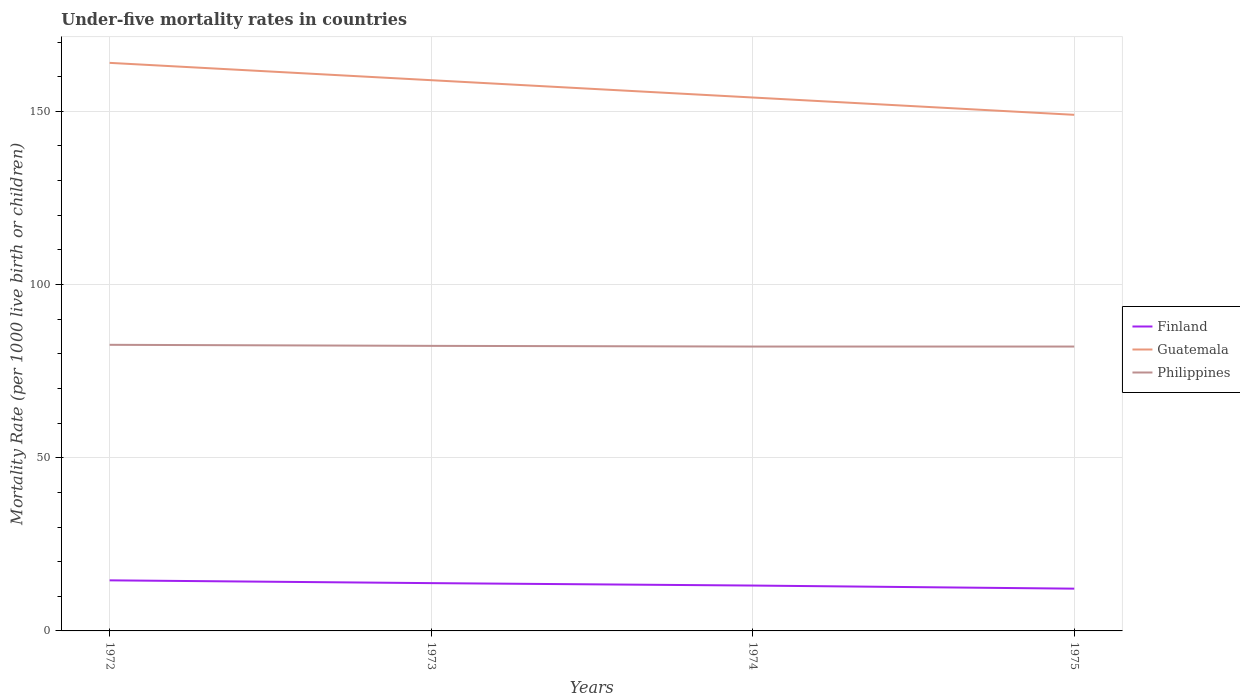How many different coloured lines are there?
Your response must be concise. 3. Does the line corresponding to Guatemala intersect with the line corresponding to Finland?
Keep it short and to the point. No. Is the number of lines equal to the number of legend labels?
Provide a succinct answer. Yes. Across all years, what is the maximum under-five mortality rate in Finland?
Your response must be concise. 12.2. In which year was the under-five mortality rate in Finland maximum?
Your response must be concise. 1975. What is the total under-five mortality rate in Guatemala in the graph?
Keep it short and to the point. 5. What is the difference between the highest and the lowest under-five mortality rate in Guatemala?
Your answer should be compact. 2. How many lines are there?
Make the answer very short. 3. What is the difference between two consecutive major ticks on the Y-axis?
Ensure brevity in your answer.  50. Does the graph contain any zero values?
Provide a succinct answer. No. Where does the legend appear in the graph?
Provide a short and direct response. Center right. How many legend labels are there?
Offer a very short reply. 3. How are the legend labels stacked?
Keep it short and to the point. Vertical. What is the title of the graph?
Offer a very short reply. Under-five mortality rates in countries. What is the label or title of the Y-axis?
Provide a succinct answer. Mortality Rate (per 1000 live birth or children). What is the Mortality Rate (per 1000 live birth or children) in Guatemala in 1972?
Give a very brief answer. 164. What is the Mortality Rate (per 1000 live birth or children) in Philippines in 1972?
Your answer should be compact. 82.6. What is the Mortality Rate (per 1000 live birth or children) in Guatemala in 1973?
Offer a very short reply. 159. What is the Mortality Rate (per 1000 live birth or children) in Philippines in 1973?
Provide a succinct answer. 82.3. What is the Mortality Rate (per 1000 live birth or children) in Finland in 1974?
Your answer should be very brief. 13.1. What is the Mortality Rate (per 1000 live birth or children) of Guatemala in 1974?
Give a very brief answer. 154. What is the Mortality Rate (per 1000 live birth or children) in Philippines in 1974?
Your answer should be very brief. 82.1. What is the Mortality Rate (per 1000 live birth or children) of Guatemala in 1975?
Offer a very short reply. 149. What is the Mortality Rate (per 1000 live birth or children) in Philippines in 1975?
Your answer should be very brief. 82.1. Across all years, what is the maximum Mortality Rate (per 1000 live birth or children) of Guatemala?
Your answer should be compact. 164. Across all years, what is the maximum Mortality Rate (per 1000 live birth or children) in Philippines?
Offer a very short reply. 82.6. Across all years, what is the minimum Mortality Rate (per 1000 live birth or children) of Guatemala?
Provide a short and direct response. 149. Across all years, what is the minimum Mortality Rate (per 1000 live birth or children) in Philippines?
Your response must be concise. 82.1. What is the total Mortality Rate (per 1000 live birth or children) in Finland in the graph?
Give a very brief answer. 53.7. What is the total Mortality Rate (per 1000 live birth or children) of Guatemala in the graph?
Offer a terse response. 626. What is the total Mortality Rate (per 1000 live birth or children) in Philippines in the graph?
Keep it short and to the point. 329.1. What is the difference between the Mortality Rate (per 1000 live birth or children) in Guatemala in 1972 and that in 1973?
Offer a terse response. 5. What is the difference between the Mortality Rate (per 1000 live birth or children) of Philippines in 1972 and that in 1973?
Provide a short and direct response. 0.3. What is the difference between the Mortality Rate (per 1000 live birth or children) in Finland in 1972 and that in 1974?
Provide a succinct answer. 1.5. What is the difference between the Mortality Rate (per 1000 live birth or children) in Philippines in 1972 and that in 1974?
Your answer should be compact. 0.5. What is the difference between the Mortality Rate (per 1000 live birth or children) of Finland in 1972 and that in 1975?
Your answer should be compact. 2.4. What is the difference between the Mortality Rate (per 1000 live birth or children) of Guatemala in 1972 and that in 1975?
Keep it short and to the point. 15. What is the difference between the Mortality Rate (per 1000 live birth or children) in Philippines in 1972 and that in 1975?
Your response must be concise. 0.5. What is the difference between the Mortality Rate (per 1000 live birth or children) in Finland in 1973 and that in 1974?
Provide a succinct answer. 0.7. What is the difference between the Mortality Rate (per 1000 live birth or children) in Philippines in 1973 and that in 1974?
Offer a very short reply. 0.2. What is the difference between the Mortality Rate (per 1000 live birth or children) in Finland in 1973 and that in 1975?
Offer a very short reply. 1.6. What is the difference between the Mortality Rate (per 1000 live birth or children) in Philippines in 1973 and that in 1975?
Provide a succinct answer. 0.2. What is the difference between the Mortality Rate (per 1000 live birth or children) in Finland in 1974 and that in 1975?
Provide a short and direct response. 0.9. What is the difference between the Mortality Rate (per 1000 live birth or children) of Finland in 1972 and the Mortality Rate (per 1000 live birth or children) of Guatemala in 1973?
Give a very brief answer. -144.4. What is the difference between the Mortality Rate (per 1000 live birth or children) of Finland in 1972 and the Mortality Rate (per 1000 live birth or children) of Philippines in 1973?
Your response must be concise. -67.7. What is the difference between the Mortality Rate (per 1000 live birth or children) of Guatemala in 1972 and the Mortality Rate (per 1000 live birth or children) of Philippines in 1973?
Provide a short and direct response. 81.7. What is the difference between the Mortality Rate (per 1000 live birth or children) in Finland in 1972 and the Mortality Rate (per 1000 live birth or children) in Guatemala in 1974?
Provide a succinct answer. -139.4. What is the difference between the Mortality Rate (per 1000 live birth or children) of Finland in 1972 and the Mortality Rate (per 1000 live birth or children) of Philippines in 1974?
Keep it short and to the point. -67.5. What is the difference between the Mortality Rate (per 1000 live birth or children) of Guatemala in 1972 and the Mortality Rate (per 1000 live birth or children) of Philippines in 1974?
Your response must be concise. 81.9. What is the difference between the Mortality Rate (per 1000 live birth or children) of Finland in 1972 and the Mortality Rate (per 1000 live birth or children) of Guatemala in 1975?
Make the answer very short. -134.4. What is the difference between the Mortality Rate (per 1000 live birth or children) in Finland in 1972 and the Mortality Rate (per 1000 live birth or children) in Philippines in 1975?
Give a very brief answer. -67.5. What is the difference between the Mortality Rate (per 1000 live birth or children) in Guatemala in 1972 and the Mortality Rate (per 1000 live birth or children) in Philippines in 1975?
Provide a short and direct response. 81.9. What is the difference between the Mortality Rate (per 1000 live birth or children) of Finland in 1973 and the Mortality Rate (per 1000 live birth or children) of Guatemala in 1974?
Offer a very short reply. -140.2. What is the difference between the Mortality Rate (per 1000 live birth or children) in Finland in 1973 and the Mortality Rate (per 1000 live birth or children) in Philippines in 1974?
Offer a terse response. -68.3. What is the difference between the Mortality Rate (per 1000 live birth or children) of Guatemala in 1973 and the Mortality Rate (per 1000 live birth or children) of Philippines in 1974?
Your response must be concise. 76.9. What is the difference between the Mortality Rate (per 1000 live birth or children) in Finland in 1973 and the Mortality Rate (per 1000 live birth or children) in Guatemala in 1975?
Your answer should be very brief. -135.2. What is the difference between the Mortality Rate (per 1000 live birth or children) in Finland in 1973 and the Mortality Rate (per 1000 live birth or children) in Philippines in 1975?
Your answer should be compact. -68.3. What is the difference between the Mortality Rate (per 1000 live birth or children) of Guatemala in 1973 and the Mortality Rate (per 1000 live birth or children) of Philippines in 1975?
Make the answer very short. 76.9. What is the difference between the Mortality Rate (per 1000 live birth or children) of Finland in 1974 and the Mortality Rate (per 1000 live birth or children) of Guatemala in 1975?
Your answer should be very brief. -135.9. What is the difference between the Mortality Rate (per 1000 live birth or children) in Finland in 1974 and the Mortality Rate (per 1000 live birth or children) in Philippines in 1975?
Provide a short and direct response. -69. What is the difference between the Mortality Rate (per 1000 live birth or children) of Guatemala in 1974 and the Mortality Rate (per 1000 live birth or children) of Philippines in 1975?
Keep it short and to the point. 71.9. What is the average Mortality Rate (per 1000 live birth or children) of Finland per year?
Your response must be concise. 13.43. What is the average Mortality Rate (per 1000 live birth or children) in Guatemala per year?
Make the answer very short. 156.5. What is the average Mortality Rate (per 1000 live birth or children) of Philippines per year?
Offer a very short reply. 82.28. In the year 1972, what is the difference between the Mortality Rate (per 1000 live birth or children) in Finland and Mortality Rate (per 1000 live birth or children) in Guatemala?
Your answer should be compact. -149.4. In the year 1972, what is the difference between the Mortality Rate (per 1000 live birth or children) in Finland and Mortality Rate (per 1000 live birth or children) in Philippines?
Ensure brevity in your answer.  -68. In the year 1972, what is the difference between the Mortality Rate (per 1000 live birth or children) in Guatemala and Mortality Rate (per 1000 live birth or children) in Philippines?
Your response must be concise. 81.4. In the year 1973, what is the difference between the Mortality Rate (per 1000 live birth or children) in Finland and Mortality Rate (per 1000 live birth or children) in Guatemala?
Keep it short and to the point. -145.2. In the year 1973, what is the difference between the Mortality Rate (per 1000 live birth or children) in Finland and Mortality Rate (per 1000 live birth or children) in Philippines?
Your answer should be very brief. -68.5. In the year 1973, what is the difference between the Mortality Rate (per 1000 live birth or children) of Guatemala and Mortality Rate (per 1000 live birth or children) of Philippines?
Give a very brief answer. 76.7. In the year 1974, what is the difference between the Mortality Rate (per 1000 live birth or children) of Finland and Mortality Rate (per 1000 live birth or children) of Guatemala?
Your answer should be very brief. -140.9. In the year 1974, what is the difference between the Mortality Rate (per 1000 live birth or children) in Finland and Mortality Rate (per 1000 live birth or children) in Philippines?
Keep it short and to the point. -69. In the year 1974, what is the difference between the Mortality Rate (per 1000 live birth or children) of Guatemala and Mortality Rate (per 1000 live birth or children) of Philippines?
Offer a very short reply. 71.9. In the year 1975, what is the difference between the Mortality Rate (per 1000 live birth or children) of Finland and Mortality Rate (per 1000 live birth or children) of Guatemala?
Offer a very short reply. -136.8. In the year 1975, what is the difference between the Mortality Rate (per 1000 live birth or children) of Finland and Mortality Rate (per 1000 live birth or children) of Philippines?
Your answer should be compact. -69.9. In the year 1975, what is the difference between the Mortality Rate (per 1000 live birth or children) of Guatemala and Mortality Rate (per 1000 live birth or children) of Philippines?
Provide a short and direct response. 66.9. What is the ratio of the Mortality Rate (per 1000 live birth or children) of Finland in 1972 to that in 1973?
Provide a succinct answer. 1.06. What is the ratio of the Mortality Rate (per 1000 live birth or children) of Guatemala in 1972 to that in 1973?
Offer a terse response. 1.03. What is the ratio of the Mortality Rate (per 1000 live birth or children) in Philippines in 1972 to that in 1973?
Your response must be concise. 1. What is the ratio of the Mortality Rate (per 1000 live birth or children) in Finland in 1972 to that in 1974?
Your response must be concise. 1.11. What is the ratio of the Mortality Rate (per 1000 live birth or children) of Guatemala in 1972 to that in 1974?
Keep it short and to the point. 1.06. What is the ratio of the Mortality Rate (per 1000 live birth or children) of Finland in 1972 to that in 1975?
Your response must be concise. 1.2. What is the ratio of the Mortality Rate (per 1000 live birth or children) in Guatemala in 1972 to that in 1975?
Make the answer very short. 1.1. What is the ratio of the Mortality Rate (per 1000 live birth or children) in Philippines in 1972 to that in 1975?
Give a very brief answer. 1.01. What is the ratio of the Mortality Rate (per 1000 live birth or children) in Finland in 1973 to that in 1974?
Give a very brief answer. 1.05. What is the ratio of the Mortality Rate (per 1000 live birth or children) in Guatemala in 1973 to that in 1974?
Your response must be concise. 1.03. What is the ratio of the Mortality Rate (per 1000 live birth or children) in Finland in 1973 to that in 1975?
Your answer should be very brief. 1.13. What is the ratio of the Mortality Rate (per 1000 live birth or children) of Guatemala in 1973 to that in 1975?
Provide a short and direct response. 1.07. What is the ratio of the Mortality Rate (per 1000 live birth or children) of Philippines in 1973 to that in 1975?
Keep it short and to the point. 1. What is the ratio of the Mortality Rate (per 1000 live birth or children) in Finland in 1974 to that in 1975?
Your answer should be very brief. 1.07. What is the ratio of the Mortality Rate (per 1000 live birth or children) of Guatemala in 1974 to that in 1975?
Make the answer very short. 1.03. What is the ratio of the Mortality Rate (per 1000 live birth or children) in Philippines in 1974 to that in 1975?
Ensure brevity in your answer.  1. What is the difference between the highest and the second highest Mortality Rate (per 1000 live birth or children) in Philippines?
Give a very brief answer. 0.3. What is the difference between the highest and the lowest Mortality Rate (per 1000 live birth or children) of Guatemala?
Offer a terse response. 15. What is the difference between the highest and the lowest Mortality Rate (per 1000 live birth or children) of Philippines?
Your answer should be compact. 0.5. 